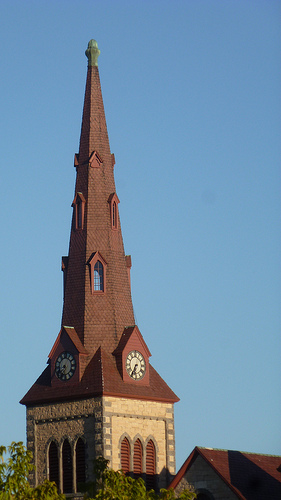How many clocks are there? There are two clocks visible on the image, each placed on different sides of the church steeple, allowing time to be seen from multiple directions. 